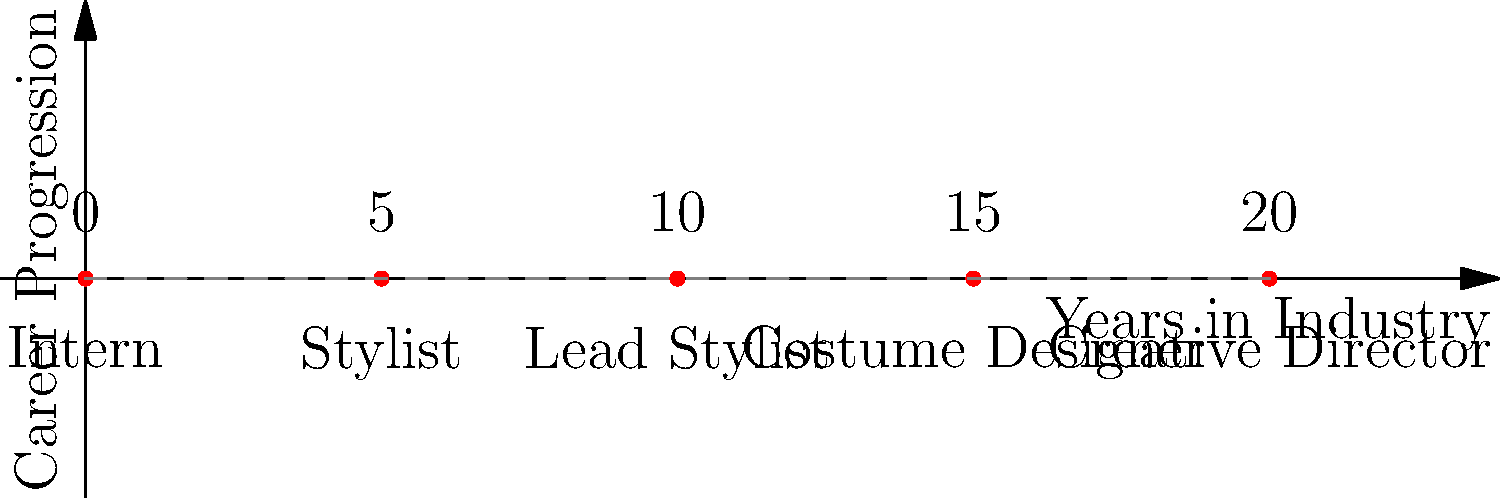Based on the timeline shown, how many years of experience are typically required to progress from a Lead Stylist to a Costume Designer in the television fashion industry? To determine the number of years typically required to progress from Lead Stylist to Costume Designer, we need to follow these steps:

1. Identify the position of Lead Stylist on the timeline:
   Lead Stylist is at the 10-year mark.

2. Identify the position of Costume Designer on the timeline:
   Costume Designer is at the 15-year mark.

3. Calculate the difference between these two positions:
   $15 \text{ years} - 10 \text{ years} = 5 \text{ years}$

Therefore, based on this timeline, it typically takes 5 years to progress from Lead Stylist to Costume Designer in the television fashion industry.
Answer: 5 years 